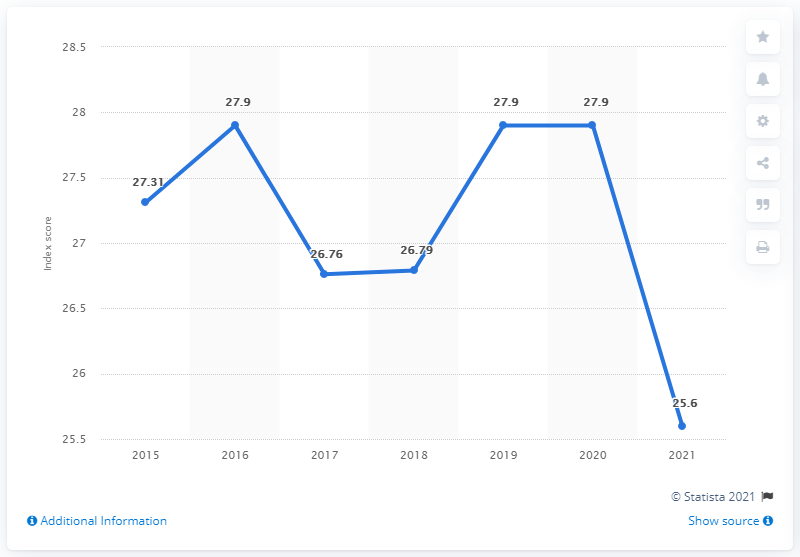What can we infer about the country's political climate based on this graph of press freedom index scores? While the graph specifically measures press freedom, the index can be reflective of the larger political climate since media freedom is often influenced by political dynamics. The decline in the index score from 27.9 in 2020 to 25.6 in 2021 might suggest increased governmental constraints on the media, legislative changes impacting journalism, or other political shifts that affect media operations and freedoms in the Dominican Republic. 